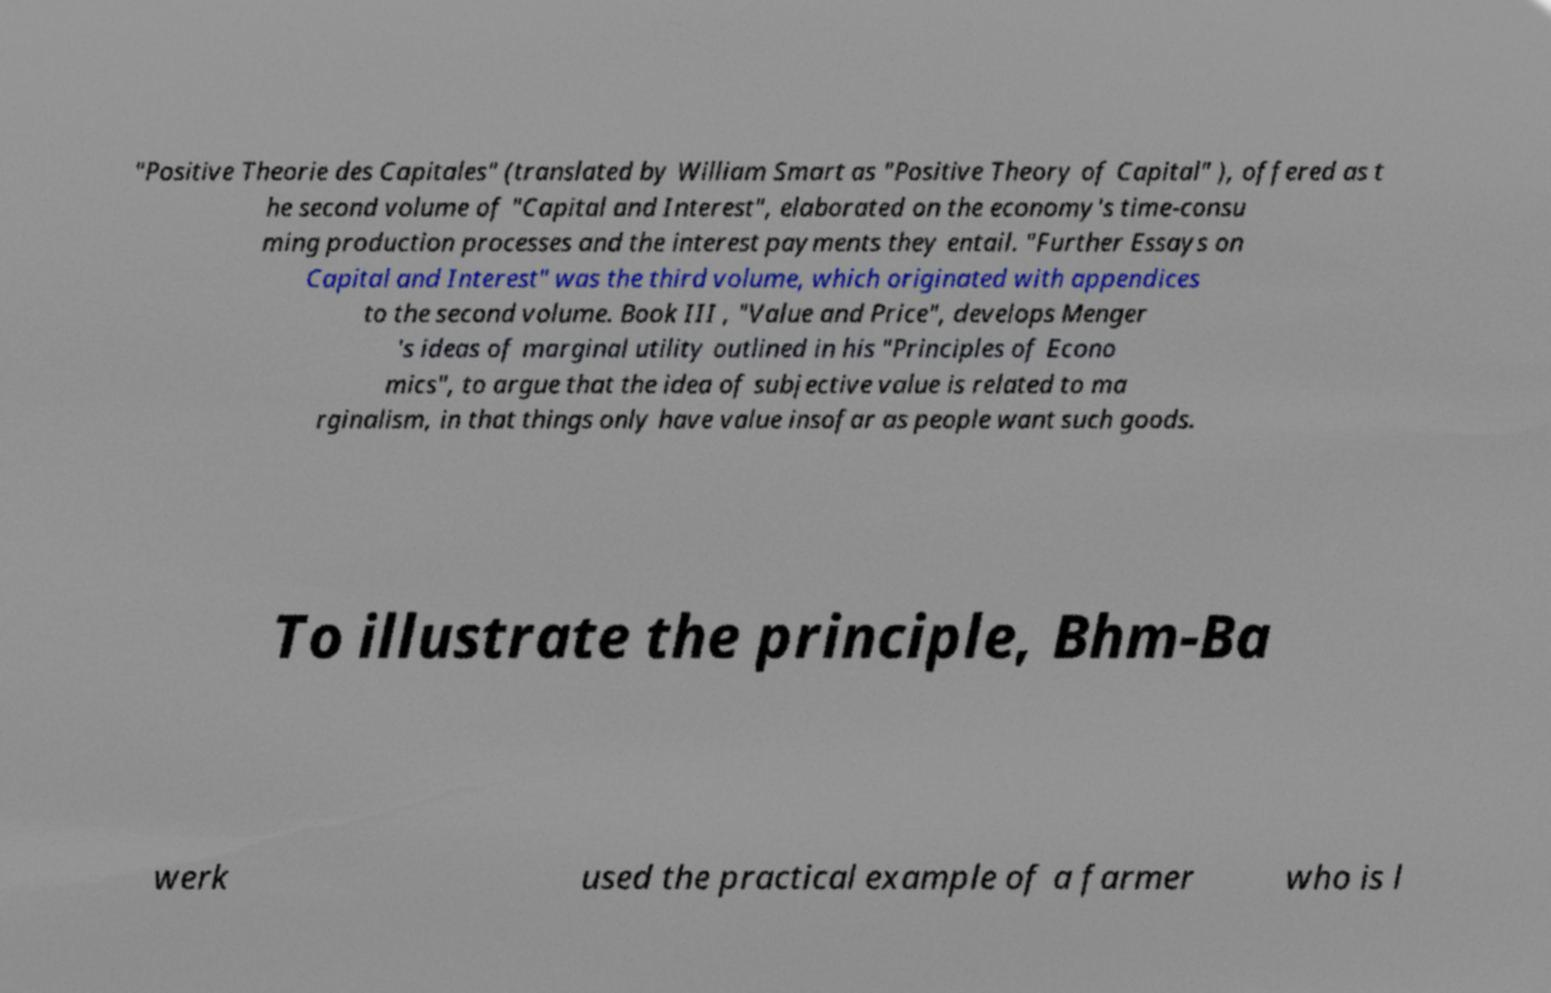Please read and relay the text visible in this image. What does it say? "Positive Theorie des Capitales" (translated by William Smart as "Positive Theory of Capital" ), offered as t he second volume of "Capital and Interest", elaborated on the economy's time-consu ming production processes and the interest payments they entail. "Further Essays on Capital and Interest" was the third volume, which originated with appendices to the second volume. Book III , "Value and Price", develops Menger 's ideas of marginal utility outlined in his "Principles of Econo mics", to argue that the idea of subjective value is related to ma rginalism, in that things only have value insofar as people want such goods. To illustrate the principle, Bhm-Ba werk used the practical example of a farmer who is l 